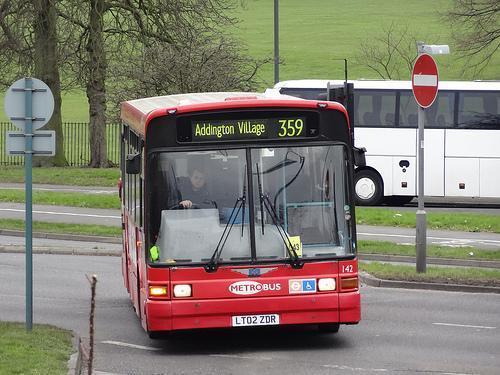How many buses are shown?
Give a very brief answer. 2. 